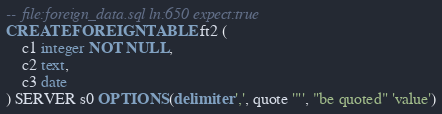Convert code to text. <code><loc_0><loc_0><loc_500><loc_500><_SQL_>-- file:foreign_data.sql ln:650 expect:true
CREATE FOREIGN TABLE ft2 (
	c1 integer NOT NULL,
	c2 text,
	c3 date
) SERVER s0 OPTIONS (delimiter ',', quote '"', "be quoted" 'value')
</code> 